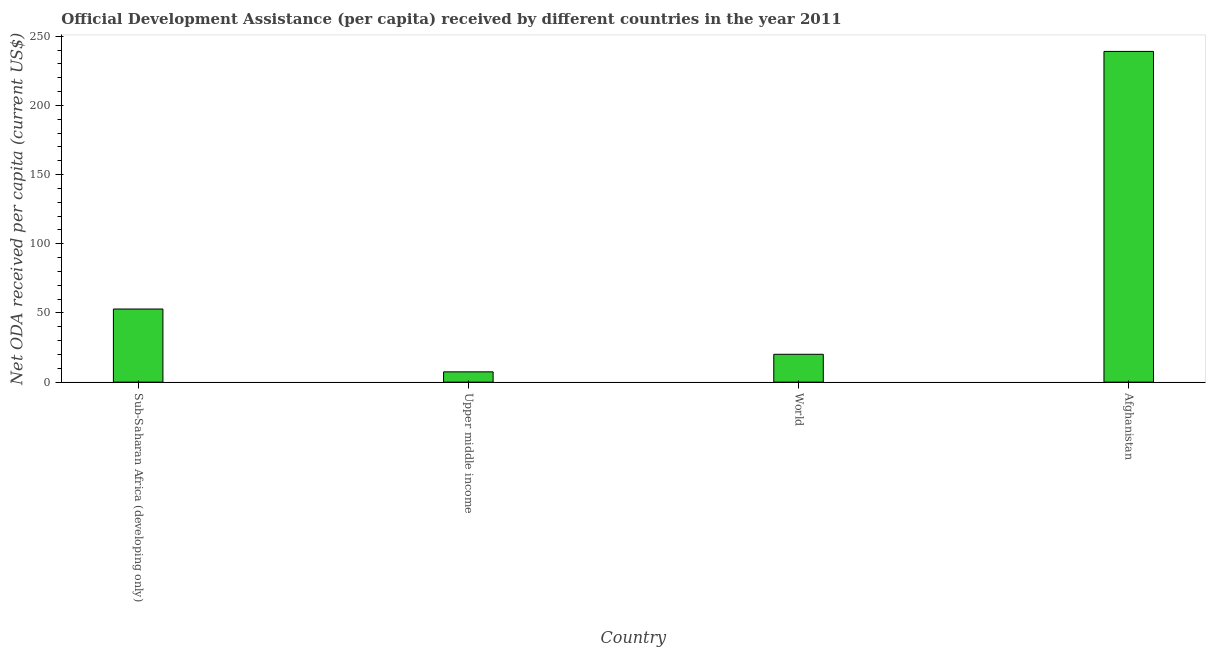Does the graph contain grids?
Your answer should be compact. No. What is the title of the graph?
Your answer should be very brief. Official Development Assistance (per capita) received by different countries in the year 2011. What is the label or title of the X-axis?
Ensure brevity in your answer.  Country. What is the label or title of the Y-axis?
Your response must be concise. Net ODA received per capita (current US$). What is the net oda received per capita in Upper middle income?
Provide a succinct answer. 7.44. Across all countries, what is the maximum net oda received per capita?
Offer a very short reply. 238.98. Across all countries, what is the minimum net oda received per capita?
Your answer should be very brief. 7.44. In which country was the net oda received per capita maximum?
Make the answer very short. Afghanistan. In which country was the net oda received per capita minimum?
Your answer should be compact. Upper middle income. What is the sum of the net oda received per capita?
Offer a terse response. 319.38. What is the difference between the net oda received per capita in Afghanistan and Upper middle income?
Keep it short and to the point. 231.54. What is the average net oda received per capita per country?
Offer a very short reply. 79.85. What is the median net oda received per capita?
Provide a short and direct response. 36.48. Is the net oda received per capita in Sub-Saharan Africa (developing only) less than that in Upper middle income?
Provide a short and direct response. No. Is the difference between the net oda received per capita in Afghanistan and World greater than the difference between any two countries?
Offer a terse response. No. What is the difference between the highest and the second highest net oda received per capita?
Ensure brevity in your answer.  186.15. Is the sum of the net oda received per capita in Sub-Saharan Africa (developing only) and World greater than the maximum net oda received per capita across all countries?
Your response must be concise. No. What is the difference between the highest and the lowest net oda received per capita?
Keep it short and to the point. 231.54. In how many countries, is the net oda received per capita greater than the average net oda received per capita taken over all countries?
Your answer should be compact. 1. How many bars are there?
Offer a very short reply. 4. What is the difference between two consecutive major ticks on the Y-axis?
Make the answer very short. 50. What is the Net ODA received per capita (current US$) in Sub-Saharan Africa (developing only)?
Make the answer very short. 52.84. What is the Net ODA received per capita (current US$) in Upper middle income?
Make the answer very short. 7.44. What is the Net ODA received per capita (current US$) in World?
Your answer should be very brief. 20.13. What is the Net ODA received per capita (current US$) in Afghanistan?
Offer a terse response. 238.98. What is the difference between the Net ODA received per capita (current US$) in Sub-Saharan Africa (developing only) and Upper middle income?
Keep it short and to the point. 45.39. What is the difference between the Net ODA received per capita (current US$) in Sub-Saharan Africa (developing only) and World?
Your response must be concise. 32.71. What is the difference between the Net ODA received per capita (current US$) in Sub-Saharan Africa (developing only) and Afghanistan?
Make the answer very short. -186.14. What is the difference between the Net ODA received per capita (current US$) in Upper middle income and World?
Your answer should be very brief. -12.68. What is the difference between the Net ODA received per capita (current US$) in Upper middle income and Afghanistan?
Your answer should be very brief. -231.54. What is the difference between the Net ODA received per capita (current US$) in World and Afghanistan?
Your response must be concise. -218.86. What is the ratio of the Net ODA received per capita (current US$) in Sub-Saharan Africa (developing only) to that in World?
Ensure brevity in your answer.  2.62. What is the ratio of the Net ODA received per capita (current US$) in Sub-Saharan Africa (developing only) to that in Afghanistan?
Ensure brevity in your answer.  0.22. What is the ratio of the Net ODA received per capita (current US$) in Upper middle income to that in World?
Offer a very short reply. 0.37. What is the ratio of the Net ODA received per capita (current US$) in Upper middle income to that in Afghanistan?
Make the answer very short. 0.03. What is the ratio of the Net ODA received per capita (current US$) in World to that in Afghanistan?
Keep it short and to the point. 0.08. 